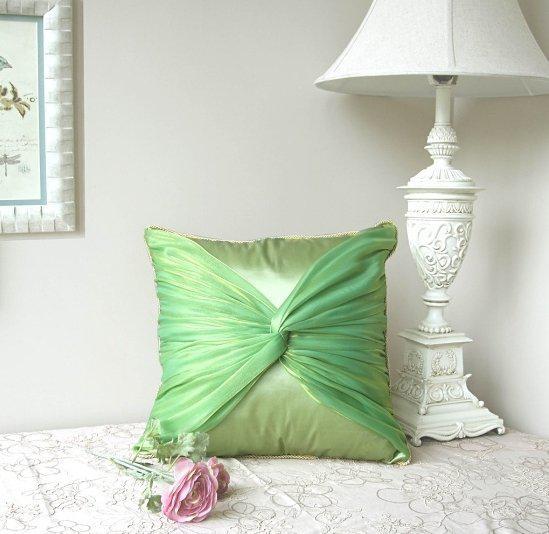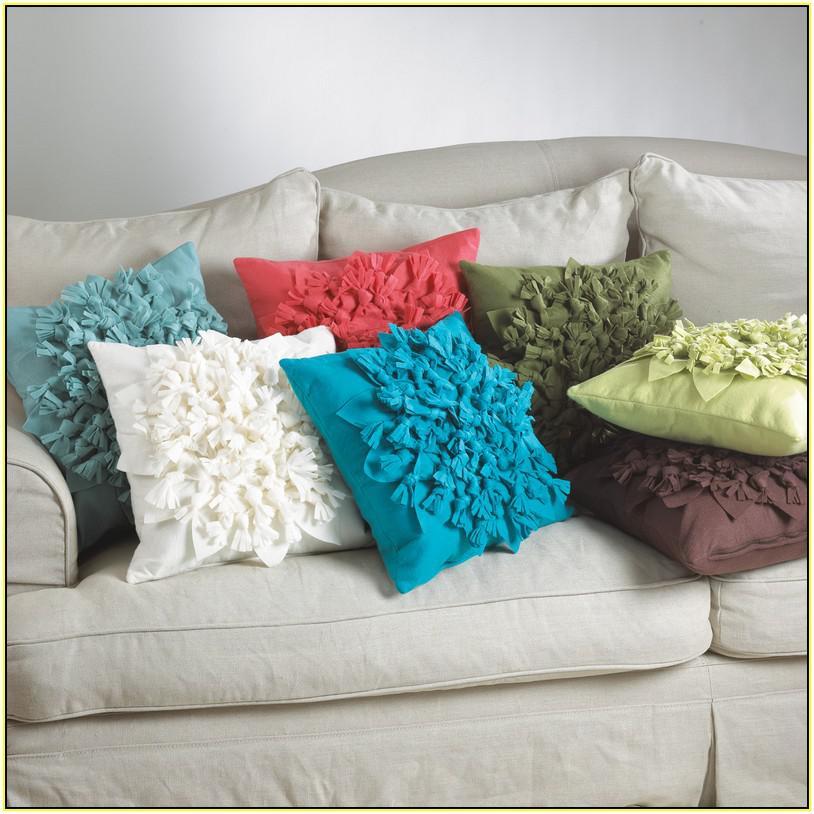The first image is the image on the left, the second image is the image on the right. For the images shown, is this caption "there are two throw pillows in the right image" true? Answer yes or no. No. The first image is the image on the left, the second image is the image on the right. For the images shown, is this caption "There are five throw pillows in each picture on the left and two throw pillows in each picture on the right." true? Answer yes or no. No. 